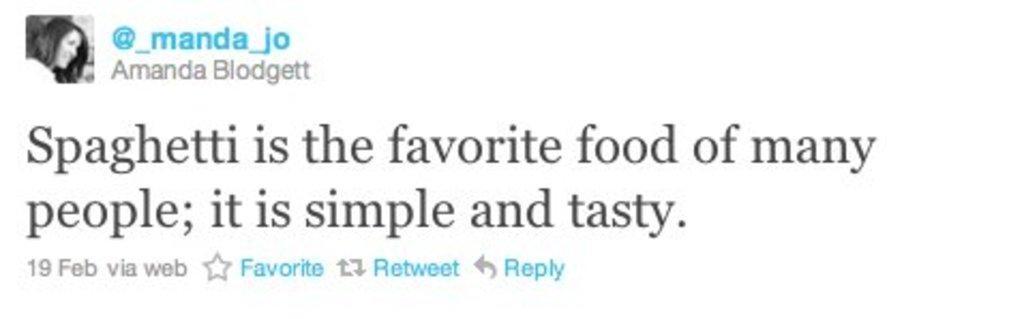How would you summarize this image in a sentence or two? In this image we can see a photo of a person. There is some text in the image. There is a white background in the image. 